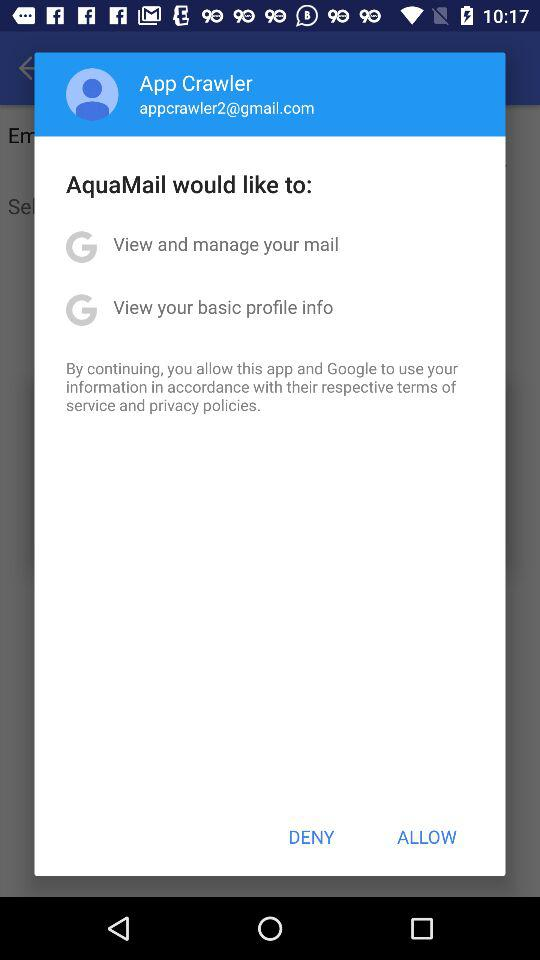What is the email ID of the user? The email ID of the user is appcrawler2@gmail.com. 